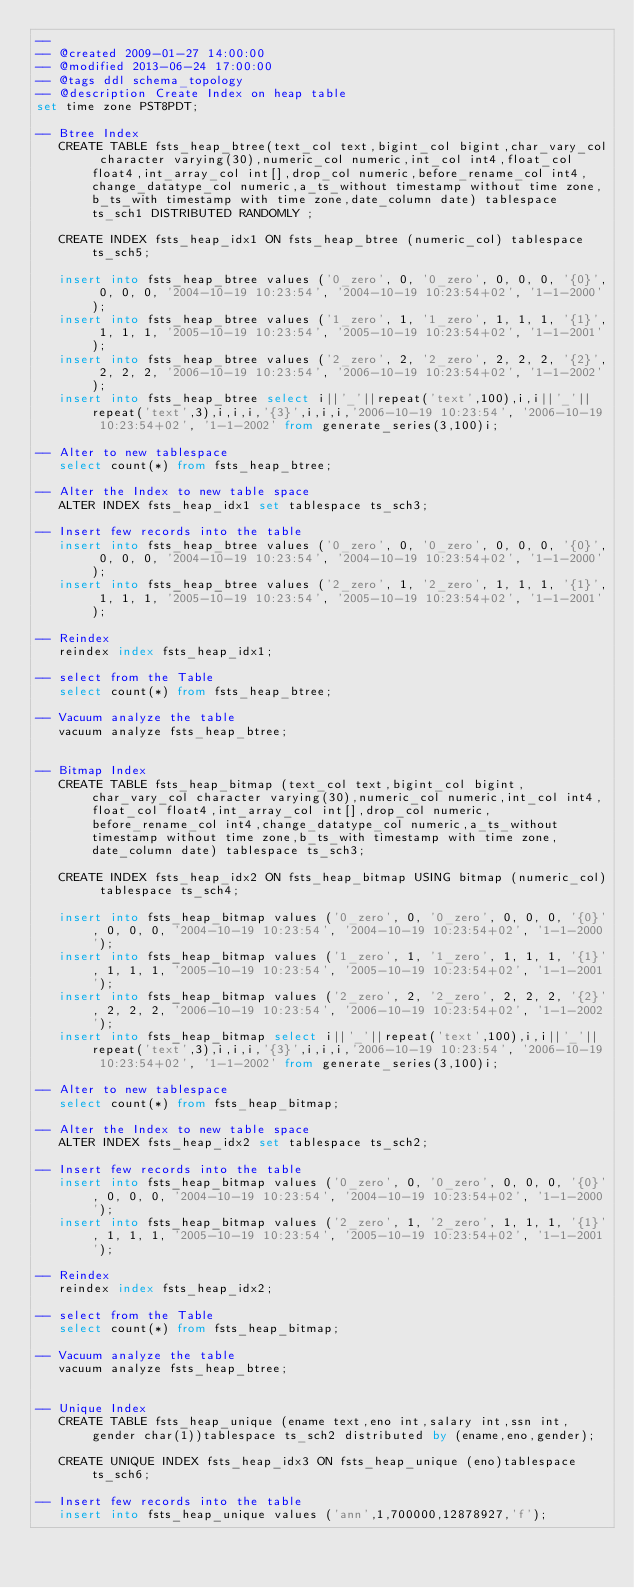Convert code to text. <code><loc_0><loc_0><loc_500><loc_500><_SQL_>-- 
-- @created 2009-01-27 14:00:00
-- @modified 2013-06-24 17:00:00
-- @tags ddl schema_topology
-- @description Create Index on heap table
set time zone PST8PDT;
   
-- Btree Index
   CREATE TABLE fsts_heap_btree(text_col text,bigint_col bigint,char_vary_col character varying(30),numeric_col numeric,int_col int4,float_col float4,int_array_col int[],drop_col numeric,before_rename_col int4,change_datatype_col numeric,a_ts_without timestamp without time zone,b_ts_with timestamp with time zone,date_column date) tablespace ts_sch1 DISTRIBUTED RANDOMLY ;
  
   CREATE INDEX fsts_heap_idx1 ON fsts_heap_btree (numeric_col) tablespace ts_sch5;

   insert into fsts_heap_btree values ('0_zero', 0, '0_zero', 0, 0, 0, '{0}', 0, 0, 0, '2004-10-19 10:23:54', '2004-10-19 10:23:54+02', '1-1-2000');
   insert into fsts_heap_btree values ('1_zero', 1, '1_zero', 1, 1, 1, '{1}', 1, 1, 1, '2005-10-19 10:23:54', '2005-10-19 10:23:54+02', '1-1-2001');
   insert into fsts_heap_btree values ('2_zero', 2, '2_zero', 2, 2, 2, '{2}', 2, 2, 2, '2006-10-19 10:23:54', '2006-10-19 10:23:54+02', '1-1-2002');
   insert into fsts_heap_btree select i||'_'||repeat('text',100),i,i||'_'||repeat('text',3),i,i,i,'{3}',i,i,i,'2006-10-19 10:23:54', '2006-10-19 10:23:54+02', '1-1-2002' from generate_series(3,100)i;

-- Alter to new tablespace
   select count(*) from fsts_heap_btree;

-- Alter the Index to new table space
   ALTER INDEX fsts_heap_idx1 set tablespace ts_sch3;

-- Insert few records into the table
   insert into fsts_heap_btree values ('0_zero', 0, '0_zero', 0, 0, 0, '{0}', 0, 0, 0, '2004-10-19 10:23:54', '2004-10-19 10:23:54+02', '1-1-2000');
   insert into fsts_heap_btree values ('2_zero', 1, '2_zero', 1, 1, 1, '{1}', 1, 1, 1, '2005-10-19 10:23:54', '2005-10-19 10:23:54+02', '1-1-2001');

-- Reindex 
   reindex index fsts_heap_idx1;

-- select from the Table
   select count(*) from fsts_heap_btree;

-- Vacuum analyze the table
   vacuum analyze fsts_heap_btree;   
   
   
-- Bitmap Index
   CREATE TABLE fsts_heap_bitmap (text_col text,bigint_col bigint,char_vary_col character varying(30),numeric_col numeric,int_col int4,float_col float4,int_array_col int[],drop_col numeric,before_rename_col int4,change_datatype_col numeric,a_ts_without timestamp without time zone,b_ts_with timestamp with time zone,date_column date) tablespace ts_sch3;
   
   CREATE INDEX fsts_heap_idx2 ON fsts_heap_bitmap USING bitmap (numeric_col) tablespace ts_sch4;

   insert into fsts_heap_bitmap values ('0_zero', 0, '0_zero', 0, 0, 0, '{0}', 0, 0, 0, '2004-10-19 10:23:54', '2004-10-19 10:23:54+02', '1-1-2000');
   insert into fsts_heap_bitmap values ('1_zero', 1, '1_zero', 1, 1, 1, '{1}', 1, 1, 1, '2005-10-19 10:23:54', '2005-10-19 10:23:54+02', '1-1-2001');
   insert into fsts_heap_bitmap values ('2_zero', 2, '2_zero', 2, 2, 2, '{2}', 2, 2, 2, '2006-10-19 10:23:54', '2006-10-19 10:23:54+02', '1-1-2002');
   insert into fsts_heap_bitmap select i||'_'||repeat('text',100),i,i||'_'||repeat('text',3),i,i,i,'{3}',i,i,i,'2006-10-19 10:23:54', '2006-10-19 10:23:54+02', '1-1-2002' from generate_series(3,100)i;

-- Alter to new tablespace
   select count(*) from fsts_heap_bitmap;

-- Alter the Index to new table space
   ALTER INDEX fsts_heap_idx2 set tablespace ts_sch2;

-- Insert few records into the table
   insert into fsts_heap_bitmap values ('0_zero', 0, '0_zero', 0, 0, 0, '{0}', 0, 0, 0, '2004-10-19 10:23:54', '2004-10-19 10:23:54+02', '1-1-2000');
   insert into fsts_heap_bitmap values ('2_zero', 1, '2_zero', 1, 1, 1, '{1}', 1, 1, 1, '2005-10-19 10:23:54', '2005-10-19 10:23:54+02', '1-1-2001');

-- Reindex 
   reindex index fsts_heap_idx2;

-- select from the Table
   select count(*) from fsts_heap_bitmap;

-- Vacuum analyze the table
   vacuum analyze fsts_heap_btree;     
   
   
-- Unique Index
   CREATE TABLE fsts_heap_unique (ename text,eno int,salary int,ssn int,gender char(1))tablespace ts_sch2 distributed by (ename,eno,gender);
   
   CREATE UNIQUE INDEX fsts_heap_idx3 ON fsts_heap_unique (eno)tablespace ts_sch6;

-- Insert few records into the table
   insert into fsts_heap_unique values ('ann',1,700000,12878927,'f');</code> 